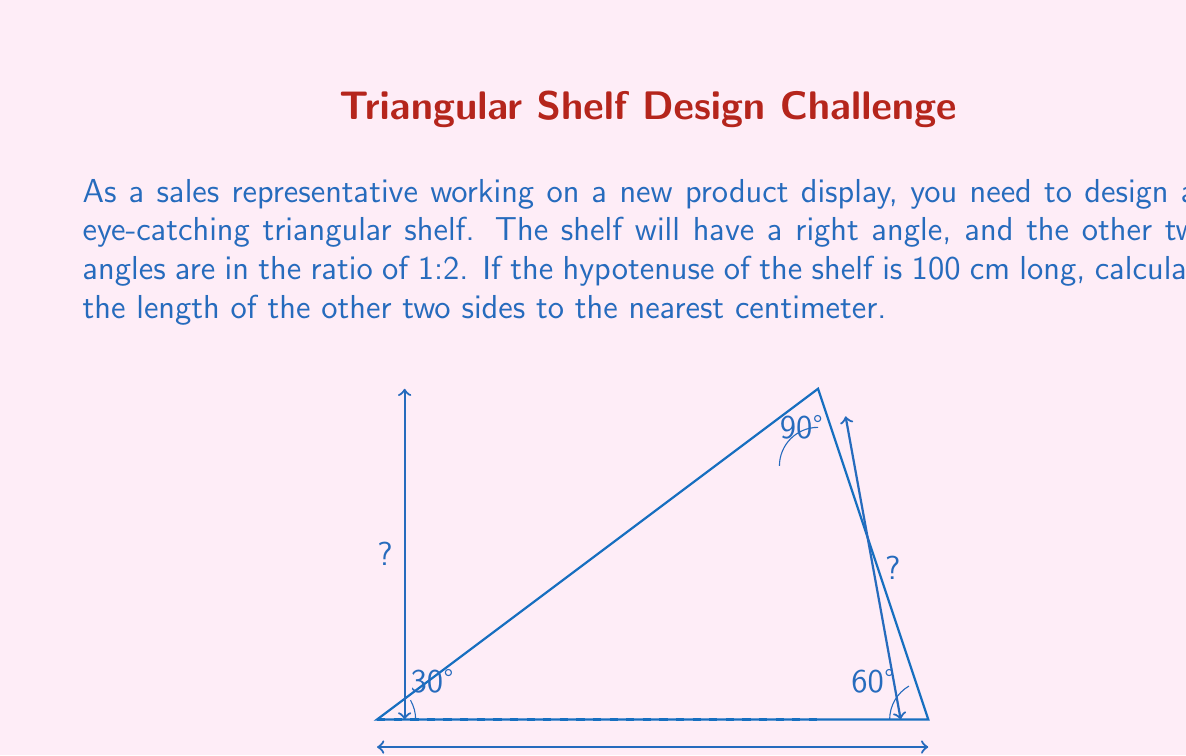Give your solution to this math problem. Let's approach this step-by-step:

1) In a right-angled triangle, if the other two angles are in the ratio 1:2, they must be 30° and 60°. This is because the angles in a triangle sum to 180°, and we know one angle is 90°:

   $$ 90° + x° + 2x° = 180° $$
   $$ 3x° = 90° $$
   $$ x = 30° $$

2) This means we're dealing with a 30-60-90 triangle. In such a triangle, if the hypotenuse is $h$, the shorter leg (opposite to 30°) is $\frac{h}{2}$, and the longer leg (opposite to 60°) is $\frac{h\sqrt{3}}{2}$.

3) We're given that the hypotenuse is 100 cm. So:

   Shorter leg = $\frac{100}{2} = 50$ cm

   Longer leg = $\frac{100\sqrt{3}}{2} \approx 86.6$ cm

4) Rounding to the nearest centimeter:

   Shorter leg = 50 cm
   Longer leg = 87 cm

Therefore, the two sides of the triangular shelf should be 50 cm and 87 cm long.
Answer: 50 cm and 87 cm 